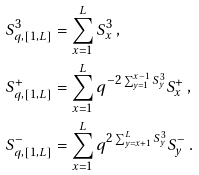<formula> <loc_0><loc_0><loc_500><loc_500>S ^ { 3 } _ { q , [ 1 , L ] } & = \sum _ { x = 1 } ^ { L } S ^ { 3 } _ { x } \, , \\ S ^ { + } _ { q , [ 1 , L ] } & = \sum _ { x = 1 } ^ { L } q ^ { - 2 \sum _ { y = 1 } ^ { x - 1 } S _ { y } ^ { 3 } } S _ { x } ^ { + } \, , \\ S ^ { - } _ { q , [ 1 , L ] } & = \sum _ { x = 1 } ^ { L } q ^ { 2 \sum _ { y = x + 1 } ^ { L } S _ { y } ^ { 3 } } S _ { y } ^ { - } \, .</formula> 